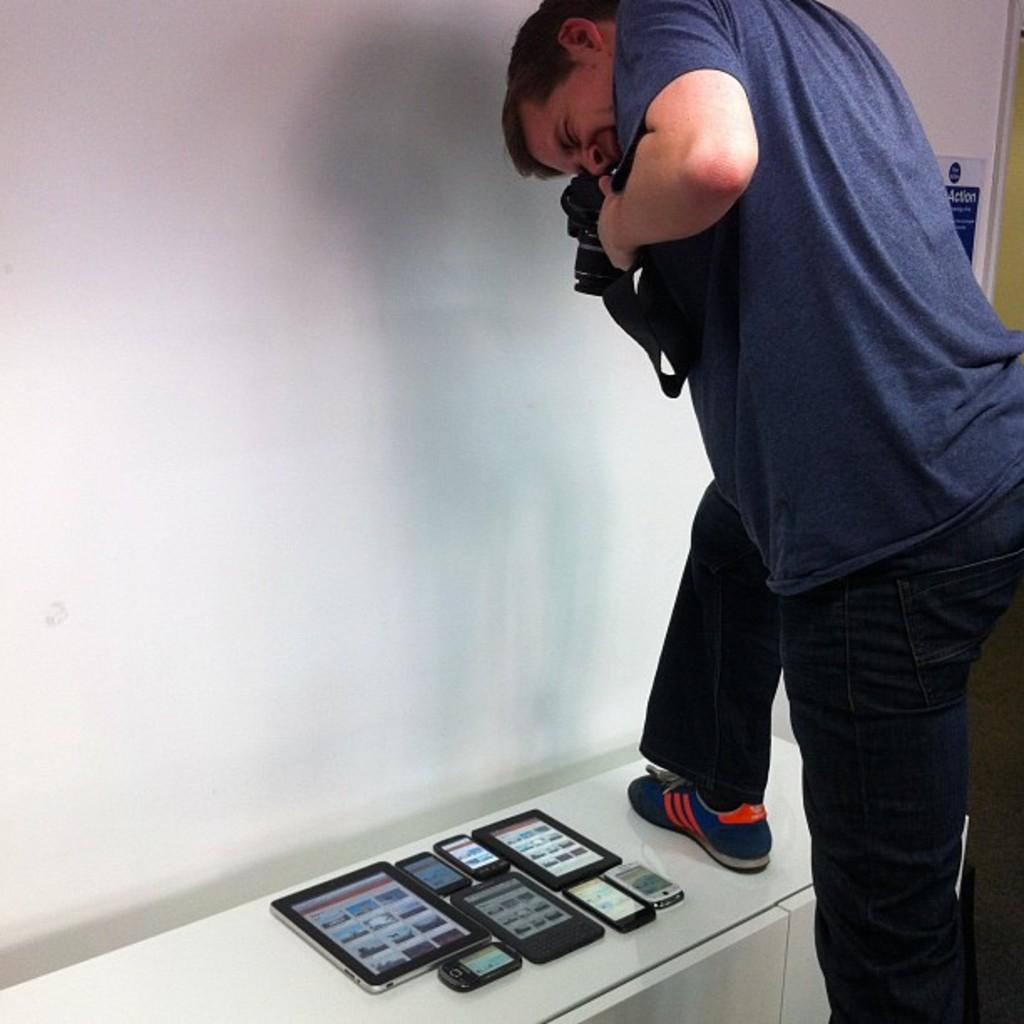Can you describe this image briefly? In this image we can see a man standing and holding the camera and capturing the photograph of the mobiles and also the tablets on the table. We can also see the wall and a poster in the background. 